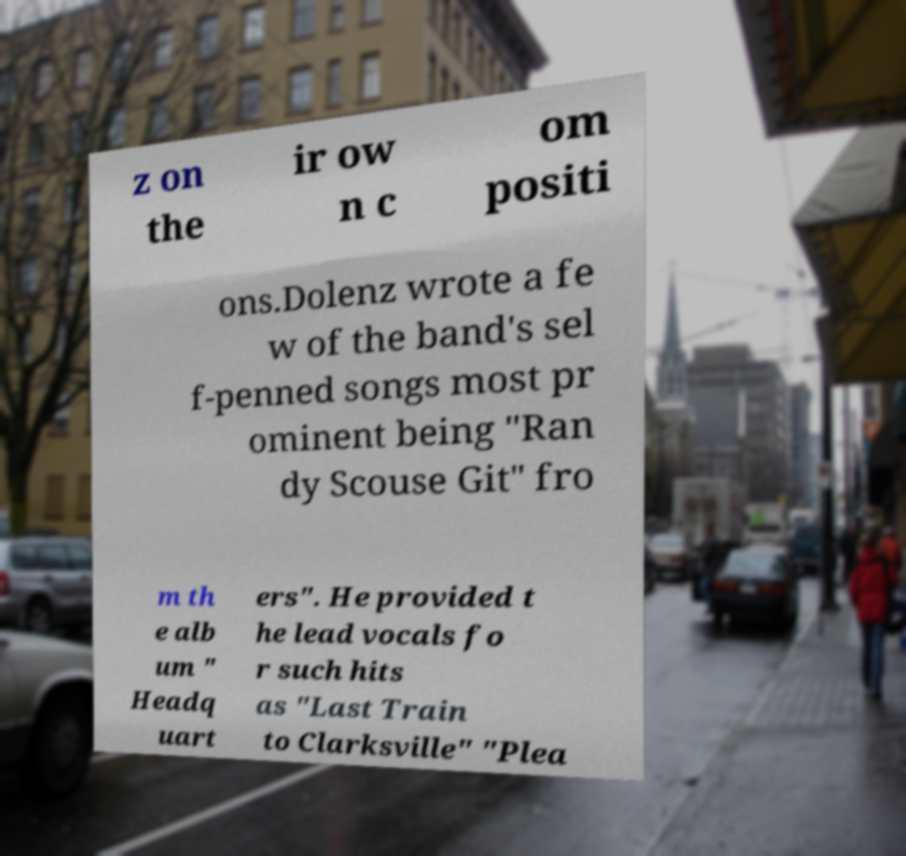For documentation purposes, I need the text within this image transcribed. Could you provide that? z on the ir ow n c om positi ons.Dolenz wrote a fe w of the band's sel f-penned songs most pr ominent being "Ran dy Scouse Git" fro m th e alb um " Headq uart ers". He provided t he lead vocals fo r such hits as "Last Train to Clarksville" "Plea 